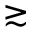<formula> <loc_0><loc_0><loc_500><loc_500>\gtrsim</formula> 